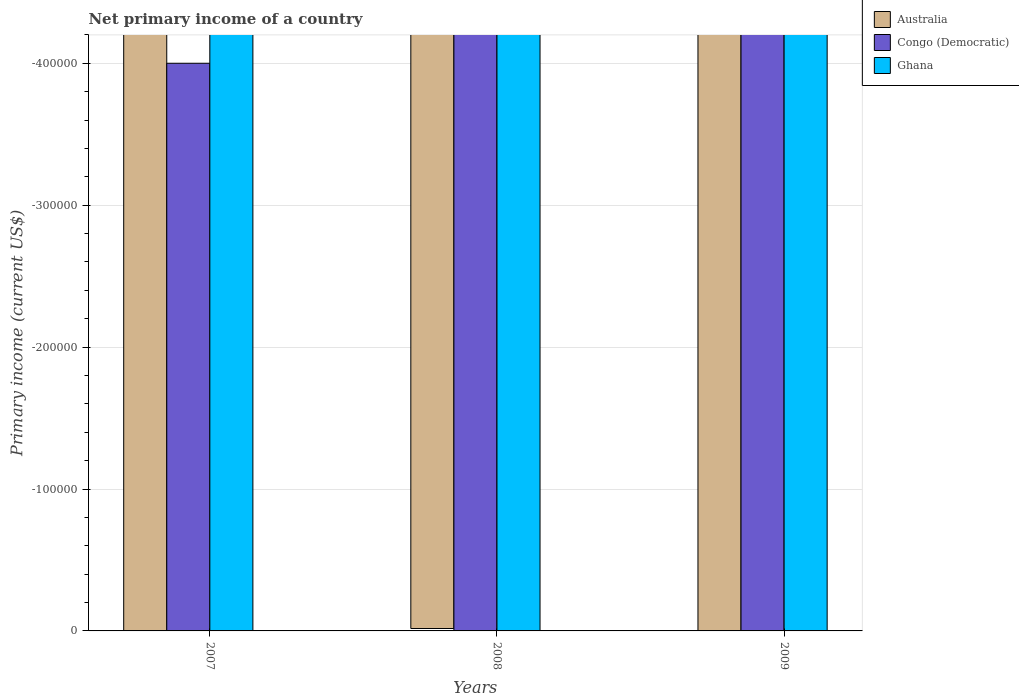What is the primary income in Australia in 2009?
Offer a very short reply. 0. Across all years, what is the minimum primary income in Congo (Democratic)?
Your response must be concise. 0. What is the average primary income in Australia per year?
Your response must be concise. 0. Is it the case that in every year, the sum of the primary income in Congo (Democratic) and primary income in Ghana is greater than the primary income in Australia?
Provide a short and direct response. No. Are all the bars in the graph horizontal?
Your answer should be compact. No. How many years are there in the graph?
Keep it short and to the point. 3. What is the difference between two consecutive major ticks on the Y-axis?
Give a very brief answer. 1.00e+05. Does the graph contain any zero values?
Offer a very short reply. Yes. Where does the legend appear in the graph?
Your response must be concise. Top right. How are the legend labels stacked?
Ensure brevity in your answer.  Vertical. What is the title of the graph?
Give a very brief answer. Net primary income of a country. Does "Samoa" appear as one of the legend labels in the graph?
Make the answer very short. No. What is the label or title of the Y-axis?
Provide a succinct answer. Primary income (current US$). What is the Primary income (current US$) of Congo (Democratic) in 2007?
Provide a short and direct response. 0. What is the Primary income (current US$) of Australia in 2009?
Give a very brief answer. 0. What is the Primary income (current US$) in Ghana in 2009?
Your answer should be very brief. 0. What is the total Primary income (current US$) of Australia in the graph?
Ensure brevity in your answer.  0. What is the total Primary income (current US$) of Congo (Democratic) in the graph?
Give a very brief answer. 0. What is the total Primary income (current US$) in Ghana in the graph?
Provide a succinct answer. 0. What is the average Primary income (current US$) in Australia per year?
Make the answer very short. 0. What is the average Primary income (current US$) in Congo (Democratic) per year?
Make the answer very short. 0. 